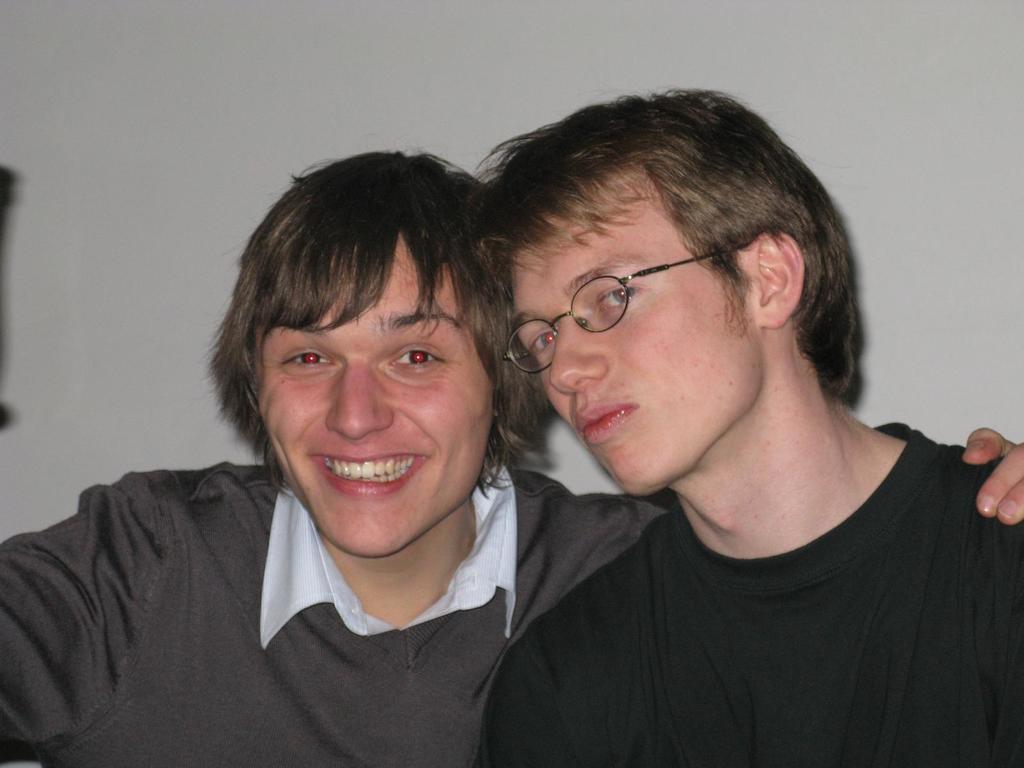Describe this image in one or two sentences. In this picture there is a man with black t-shirt and there is a man with white shirt is smiling. At the back there is a wall. 